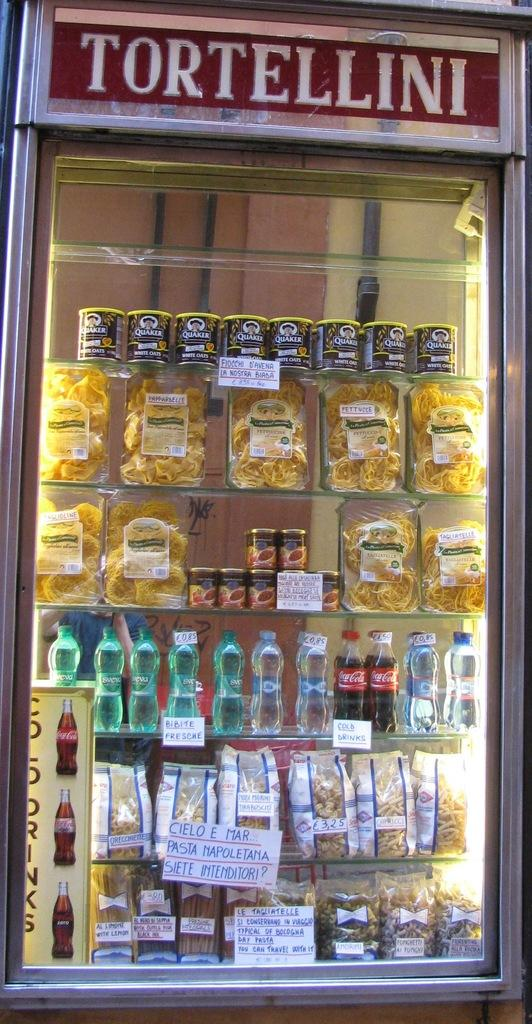What type of appliance is present in the image? There is a refrigerator in the image. What items are stored inside the refrigerator? There are bottles in the image. What else can be seen in the image besides the refrigerator and bottles? There are packets in the image. Can you see a man holding a receipt and riding a donkey in the image? There is no man, receipt, or donkey present in the image. 